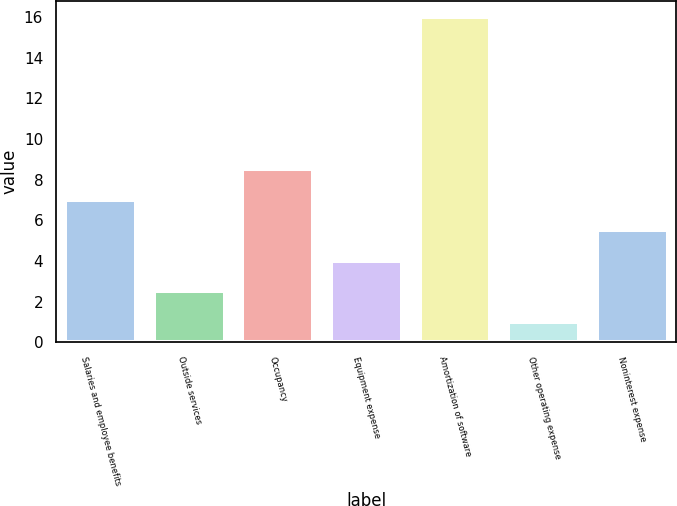Convert chart to OTSL. <chart><loc_0><loc_0><loc_500><loc_500><bar_chart><fcel>Salaries and employee benefits<fcel>Outside services<fcel>Occupancy<fcel>Equipment expense<fcel>Amortization of software<fcel>Other operating expense<fcel>Noninterest expense<nl><fcel>7<fcel>2.5<fcel>8.5<fcel>4<fcel>16<fcel>1<fcel>5.5<nl></chart> 